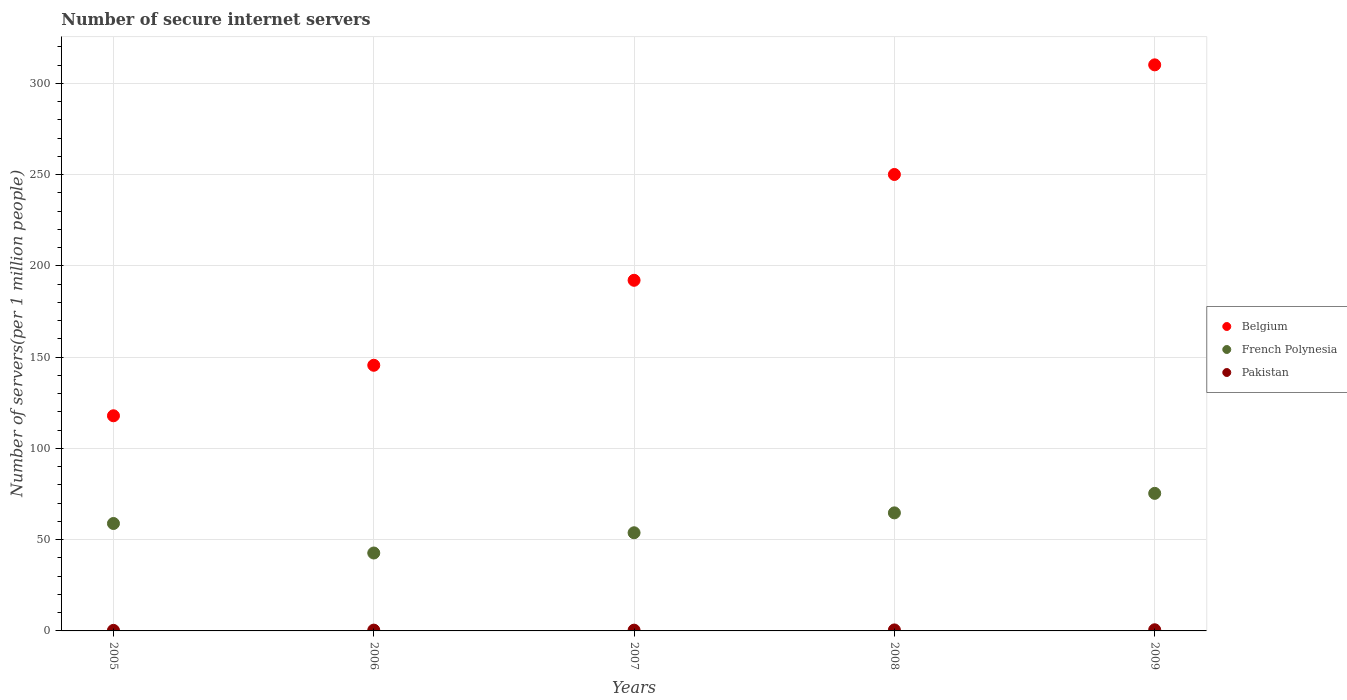Is the number of dotlines equal to the number of legend labels?
Your answer should be compact. Yes. What is the number of secure internet servers in Belgium in 2009?
Ensure brevity in your answer.  310.1. Across all years, what is the maximum number of secure internet servers in French Polynesia?
Your answer should be compact. 75.35. Across all years, what is the minimum number of secure internet servers in French Polynesia?
Give a very brief answer. 42.68. In which year was the number of secure internet servers in Pakistan maximum?
Your answer should be very brief. 2009. What is the total number of secure internet servers in French Polynesia in the graph?
Keep it short and to the point. 295.33. What is the difference between the number of secure internet servers in French Polynesia in 2006 and that in 2009?
Ensure brevity in your answer.  -32.67. What is the difference between the number of secure internet servers in Belgium in 2005 and the number of secure internet servers in French Polynesia in 2007?
Your answer should be compact. 64.09. What is the average number of secure internet servers in French Polynesia per year?
Make the answer very short. 59.07. In the year 2005, what is the difference between the number of secure internet servers in French Polynesia and number of secure internet servers in Belgium?
Provide a succinct answer. -59.01. What is the ratio of the number of secure internet servers in Belgium in 2007 to that in 2008?
Keep it short and to the point. 0.77. Is the number of secure internet servers in Pakistan in 2008 less than that in 2009?
Offer a terse response. Yes. Is the difference between the number of secure internet servers in French Polynesia in 2005 and 2007 greater than the difference between the number of secure internet servers in Belgium in 2005 and 2007?
Make the answer very short. Yes. What is the difference between the highest and the second highest number of secure internet servers in Pakistan?
Make the answer very short. 0.08. What is the difference between the highest and the lowest number of secure internet servers in Belgium?
Make the answer very short. 192.24. In how many years, is the number of secure internet servers in Pakistan greater than the average number of secure internet servers in Pakistan taken over all years?
Keep it short and to the point. 2. Does the number of secure internet servers in Pakistan monotonically increase over the years?
Your answer should be compact. No. How many years are there in the graph?
Make the answer very short. 5. What is the difference between two consecutive major ticks on the Y-axis?
Your response must be concise. 50. Where does the legend appear in the graph?
Keep it short and to the point. Center right. How many legend labels are there?
Your answer should be very brief. 3. What is the title of the graph?
Your answer should be very brief. Number of secure internet servers. Does "Central Europe" appear as one of the legend labels in the graph?
Offer a terse response. No. What is the label or title of the X-axis?
Offer a terse response. Years. What is the label or title of the Y-axis?
Your response must be concise. Number of servers(per 1 million people). What is the Number of servers(per 1 million people) in Belgium in 2005?
Give a very brief answer. 117.86. What is the Number of servers(per 1 million people) in French Polynesia in 2005?
Provide a succinct answer. 58.85. What is the Number of servers(per 1 million people) in Pakistan in 2005?
Ensure brevity in your answer.  0.3. What is the Number of servers(per 1 million people) of Belgium in 2006?
Offer a very short reply. 145.53. What is the Number of servers(per 1 million people) of French Polynesia in 2006?
Provide a succinct answer. 42.68. What is the Number of servers(per 1 million people) of Pakistan in 2006?
Your answer should be very brief. 0.44. What is the Number of servers(per 1 million people) of Belgium in 2007?
Your answer should be compact. 192.08. What is the Number of servers(per 1 million people) in French Polynesia in 2007?
Keep it short and to the point. 53.77. What is the Number of servers(per 1 million people) in Pakistan in 2007?
Offer a terse response. 0.42. What is the Number of servers(per 1 million people) in Belgium in 2008?
Give a very brief answer. 250.05. What is the Number of servers(per 1 million people) in French Polynesia in 2008?
Your response must be concise. 64.67. What is the Number of servers(per 1 million people) in Pakistan in 2008?
Offer a terse response. 0.55. What is the Number of servers(per 1 million people) of Belgium in 2009?
Offer a very short reply. 310.1. What is the Number of servers(per 1 million people) in French Polynesia in 2009?
Your answer should be very brief. 75.35. What is the Number of servers(per 1 million people) of Pakistan in 2009?
Offer a very short reply. 0.63. Across all years, what is the maximum Number of servers(per 1 million people) of Belgium?
Your answer should be compact. 310.1. Across all years, what is the maximum Number of servers(per 1 million people) in French Polynesia?
Offer a very short reply. 75.35. Across all years, what is the maximum Number of servers(per 1 million people) in Pakistan?
Your answer should be compact. 0.63. Across all years, what is the minimum Number of servers(per 1 million people) of Belgium?
Keep it short and to the point. 117.86. Across all years, what is the minimum Number of servers(per 1 million people) of French Polynesia?
Ensure brevity in your answer.  42.68. Across all years, what is the minimum Number of servers(per 1 million people) of Pakistan?
Provide a short and direct response. 0.3. What is the total Number of servers(per 1 million people) in Belgium in the graph?
Offer a terse response. 1015.61. What is the total Number of servers(per 1 million people) in French Polynesia in the graph?
Provide a short and direct response. 295.33. What is the total Number of servers(per 1 million people) in Pakistan in the graph?
Your response must be concise. 2.34. What is the difference between the Number of servers(per 1 million people) in Belgium in 2005 and that in 2006?
Offer a very short reply. -27.67. What is the difference between the Number of servers(per 1 million people) of French Polynesia in 2005 and that in 2006?
Give a very brief answer. 16.17. What is the difference between the Number of servers(per 1 million people) of Pakistan in 2005 and that in 2006?
Your answer should be very brief. -0.14. What is the difference between the Number of servers(per 1 million people) of Belgium in 2005 and that in 2007?
Keep it short and to the point. -74.22. What is the difference between the Number of servers(per 1 million people) of French Polynesia in 2005 and that in 2007?
Give a very brief answer. 5.08. What is the difference between the Number of servers(per 1 million people) of Pakistan in 2005 and that in 2007?
Provide a short and direct response. -0.12. What is the difference between the Number of servers(per 1 million people) in Belgium in 2005 and that in 2008?
Ensure brevity in your answer.  -132.19. What is the difference between the Number of servers(per 1 million people) in French Polynesia in 2005 and that in 2008?
Your answer should be compact. -5.82. What is the difference between the Number of servers(per 1 million people) of Pakistan in 2005 and that in 2008?
Your answer should be very brief. -0.25. What is the difference between the Number of servers(per 1 million people) in Belgium in 2005 and that in 2009?
Offer a terse response. -192.24. What is the difference between the Number of servers(per 1 million people) of French Polynesia in 2005 and that in 2009?
Your response must be concise. -16.5. What is the difference between the Number of servers(per 1 million people) of Pakistan in 2005 and that in 2009?
Provide a succinct answer. -0.33. What is the difference between the Number of servers(per 1 million people) of Belgium in 2006 and that in 2007?
Keep it short and to the point. -46.56. What is the difference between the Number of servers(per 1 million people) of French Polynesia in 2006 and that in 2007?
Your response must be concise. -11.09. What is the difference between the Number of servers(per 1 million people) of Pakistan in 2006 and that in 2007?
Offer a very short reply. 0.02. What is the difference between the Number of servers(per 1 million people) in Belgium in 2006 and that in 2008?
Provide a succinct answer. -104.52. What is the difference between the Number of servers(per 1 million people) of French Polynesia in 2006 and that in 2008?
Offer a very short reply. -21.99. What is the difference between the Number of servers(per 1 million people) in Pakistan in 2006 and that in 2008?
Provide a succinct answer. -0.1. What is the difference between the Number of servers(per 1 million people) of Belgium in 2006 and that in 2009?
Provide a succinct answer. -164.57. What is the difference between the Number of servers(per 1 million people) in French Polynesia in 2006 and that in 2009?
Ensure brevity in your answer.  -32.67. What is the difference between the Number of servers(per 1 million people) in Pakistan in 2006 and that in 2009?
Make the answer very short. -0.19. What is the difference between the Number of servers(per 1 million people) in Belgium in 2007 and that in 2008?
Offer a very short reply. -57.97. What is the difference between the Number of servers(per 1 million people) of French Polynesia in 2007 and that in 2008?
Offer a terse response. -10.9. What is the difference between the Number of servers(per 1 million people) of Pakistan in 2007 and that in 2008?
Your answer should be very brief. -0.13. What is the difference between the Number of servers(per 1 million people) of Belgium in 2007 and that in 2009?
Give a very brief answer. -118.02. What is the difference between the Number of servers(per 1 million people) of French Polynesia in 2007 and that in 2009?
Your answer should be very brief. -21.58. What is the difference between the Number of servers(per 1 million people) in Pakistan in 2007 and that in 2009?
Provide a short and direct response. -0.21. What is the difference between the Number of servers(per 1 million people) of Belgium in 2008 and that in 2009?
Provide a succinct answer. -60.05. What is the difference between the Number of servers(per 1 million people) in French Polynesia in 2008 and that in 2009?
Your answer should be compact. -10.69. What is the difference between the Number of servers(per 1 million people) of Pakistan in 2008 and that in 2009?
Your answer should be compact. -0.08. What is the difference between the Number of servers(per 1 million people) of Belgium in 2005 and the Number of servers(per 1 million people) of French Polynesia in 2006?
Your answer should be compact. 75.18. What is the difference between the Number of servers(per 1 million people) in Belgium in 2005 and the Number of servers(per 1 million people) in Pakistan in 2006?
Offer a very short reply. 117.42. What is the difference between the Number of servers(per 1 million people) of French Polynesia in 2005 and the Number of servers(per 1 million people) of Pakistan in 2006?
Provide a short and direct response. 58.41. What is the difference between the Number of servers(per 1 million people) of Belgium in 2005 and the Number of servers(per 1 million people) of French Polynesia in 2007?
Give a very brief answer. 64.09. What is the difference between the Number of servers(per 1 million people) in Belgium in 2005 and the Number of servers(per 1 million people) in Pakistan in 2007?
Your answer should be very brief. 117.44. What is the difference between the Number of servers(per 1 million people) of French Polynesia in 2005 and the Number of servers(per 1 million people) of Pakistan in 2007?
Keep it short and to the point. 58.43. What is the difference between the Number of servers(per 1 million people) of Belgium in 2005 and the Number of servers(per 1 million people) of French Polynesia in 2008?
Offer a very short reply. 53.19. What is the difference between the Number of servers(per 1 million people) in Belgium in 2005 and the Number of servers(per 1 million people) in Pakistan in 2008?
Keep it short and to the point. 117.31. What is the difference between the Number of servers(per 1 million people) of French Polynesia in 2005 and the Number of servers(per 1 million people) of Pakistan in 2008?
Provide a short and direct response. 58.3. What is the difference between the Number of servers(per 1 million people) of Belgium in 2005 and the Number of servers(per 1 million people) of French Polynesia in 2009?
Give a very brief answer. 42.5. What is the difference between the Number of servers(per 1 million people) of Belgium in 2005 and the Number of servers(per 1 million people) of Pakistan in 2009?
Your answer should be compact. 117.23. What is the difference between the Number of servers(per 1 million people) in French Polynesia in 2005 and the Number of servers(per 1 million people) in Pakistan in 2009?
Provide a succinct answer. 58.22. What is the difference between the Number of servers(per 1 million people) in Belgium in 2006 and the Number of servers(per 1 million people) in French Polynesia in 2007?
Provide a short and direct response. 91.75. What is the difference between the Number of servers(per 1 million people) of Belgium in 2006 and the Number of servers(per 1 million people) of Pakistan in 2007?
Your answer should be very brief. 145.11. What is the difference between the Number of servers(per 1 million people) of French Polynesia in 2006 and the Number of servers(per 1 million people) of Pakistan in 2007?
Offer a terse response. 42.26. What is the difference between the Number of servers(per 1 million people) in Belgium in 2006 and the Number of servers(per 1 million people) in French Polynesia in 2008?
Offer a terse response. 80.86. What is the difference between the Number of servers(per 1 million people) in Belgium in 2006 and the Number of servers(per 1 million people) in Pakistan in 2008?
Your answer should be compact. 144.98. What is the difference between the Number of servers(per 1 million people) in French Polynesia in 2006 and the Number of servers(per 1 million people) in Pakistan in 2008?
Offer a terse response. 42.13. What is the difference between the Number of servers(per 1 million people) in Belgium in 2006 and the Number of servers(per 1 million people) in French Polynesia in 2009?
Provide a short and direct response. 70.17. What is the difference between the Number of servers(per 1 million people) of Belgium in 2006 and the Number of servers(per 1 million people) of Pakistan in 2009?
Make the answer very short. 144.9. What is the difference between the Number of servers(per 1 million people) of French Polynesia in 2006 and the Number of servers(per 1 million people) of Pakistan in 2009?
Make the answer very short. 42.05. What is the difference between the Number of servers(per 1 million people) in Belgium in 2007 and the Number of servers(per 1 million people) in French Polynesia in 2008?
Ensure brevity in your answer.  127.41. What is the difference between the Number of servers(per 1 million people) of Belgium in 2007 and the Number of servers(per 1 million people) of Pakistan in 2008?
Ensure brevity in your answer.  191.54. What is the difference between the Number of servers(per 1 million people) of French Polynesia in 2007 and the Number of servers(per 1 million people) of Pakistan in 2008?
Your answer should be very brief. 53.23. What is the difference between the Number of servers(per 1 million people) in Belgium in 2007 and the Number of servers(per 1 million people) in French Polynesia in 2009?
Offer a very short reply. 116.73. What is the difference between the Number of servers(per 1 million people) in Belgium in 2007 and the Number of servers(per 1 million people) in Pakistan in 2009?
Provide a succinct answer. 191.45. What is the difference between the Number of servers(per 1 million people) in French Polynesia in 2007 and the Number of servers(per 1 million people) in Pakistan in 2009?
Provide a short and direct response. 53.14. What is the difference between the Number of servers(per 1 million people) in Belgium in 2008 and the Number of servers(per 1 million people) in French Polynesia in 2009?
Give a very brief answer. 174.69. What is the difference between the Number of servers(per 1 million people) of Belgium in 2008 and the Number of servers(per 1 million people) of Pakistan in 2009?
Make the answer very short. 249.42. What is the difference between the Number of servers(per 1 million people) in French Polynesia in 2008 and the Number of servers(per 1 million people) in Pakistan in 2009?
Provide a succinct answer. 64.04. What is the average Number of servers(per 1 million people) in Belgium per year?
Make the answer very short. 203.12. What is the average Number of servers(per 1 million people) in French Polynesia per year?
Offer a very short reply. 59.07. What is the average Number of servers(per 1 million people) in Pakistan per year?
Keep it short and to the point. 0.47. In the year 2005, what is the difference between the Number of servers(per 1 million people) in Belgium and Number of servers(per 1 million people) in French Polynesia?
Make the answer very short. 59.01. In the year 2005, what is the difference between the Number of servers(per 1 million people) in Belgium and Number of servers(per 1 million people) in Pakistan?
Your response must be concise. 117.56. In the year 2005, what is the difference between the Number of servers(per 1 million people) in French Polynesia and Number of servers(per 1 million people) in Pakistan?
Provide a succinct answer. 58.55. In the year 2006, what is the difference between the Number of servers(per 1 million people) in Belgium and Number of servers(per 1 million people) in French Polynesia?
Ensure brevity in your answer.  102.85. In the year 2006, what is the difference between the Number of servers(per 1 million people) in Belgium and Number of servers(per 1 million people) in Pakistan?
Provide a succinct answer. 145.09. In the year 2006, what is the difference between the Number of servers(per 1 million people) in French Polynesia and Number of servers(per 1 million people) in Pakistan?
Make the answer very short. 42.24. In the year 2007, what is the difference between the Number of servers(per 1 million people) of Belgium and Number of servers(per 1 million people) of French Polynesia?
Your answer should be compact. 138.31. In the year 2007, what is the difference between the Number of servers(per 1 million people) in Belgium and Number of servers(per 1 million people) in Pakistan?
Your response must be concise. 191.66. In the year 2007, what is the difference between the Number of servers(per 1 million people) in French Polynesia and Number of servers(per 1 million people) in Pakistan?
Provide a short and direct response. 53.35. In the year 2008, what is the difference between the Number of servers(per 1 million people) of Belgium and Number of servers(per 1 million people) of French Polynesia?
Keep it short and to the point. 185.38. In the year 2008, what is the difference between the Number of servers(per 1 million people) in Belgium and Number of servers(per 1 million people) in Pakistan?
Make the answer very short. 249.5. In the year 2008, what is the difference between the Number of servers(per 1 million people) of French Polynesia and Number of servers(per 1 million people) of Pakistan?
Your answer should be very brief. 64.12. In the year 2009, what is the difference between the Number of servers(per 1 million people) in Belgium and Number of servers(per 1 million people) in French Polynesia?
Keep it short and to the point. 234.75. In the year 2009, what is the difference between the Number of servers(per 1 million people) in Belgium and Number of servers(per 1 million people) in Pakistan?
Provide a succinct answer. 309.47. In the year 2009, what is the difference between the Number of servers(per 1 million people) in French Polynesia and Number of servers(per 1 million people) in Pakistan?
Your answer should be very brief. 74.72. What is the ratio of the Number of servers(per 1 million people) in Belgium in 2005 to that in 2006?
Provide a succinct answer. 0.81. What is the ratio of the Number of servers(per 1 million people) in French Polynesia in 2005 to that in 2006?
Give a very brief answer. 1.38. What is the ratio of the Number of servers(per 1 million people) of Pakistan in 2005 to that in 2006?
Your answer should be compact. 0.68. What is the ratio of the Number of servers(per 1 million people) of Belgium in 2005 to that in 2007?
Provide a short and direct response. 0.61. What is the ratio of the Number of servers(per 1 million people) of French Polynesia in 2005 to that in 2007?
Offer a very short reply. 1.09. What is the ratio of the Number of servers(per 1 million people) of Pakistan in 2005 to that in 2007?
Offer a very short reply. 0.72. What is the ratio of the Number of servers(per 1 million people) of Belgium in 2005 to that in 2008?
Your response must be concise. 0.47. What is the ratio of the Number of servers(per 1 million people) in French Polynesia in 2005 to that in 2008?
Make the answer very short. 0.91. What is the ratio of the Number of servers(per 1 million people) of Pakistan in 2005 to that in 2008?
Make the answer very short. 0.55. What is the ratio of the Number of servers(per 1 million people) in Belgium in 2005 to that in 2009?
Your response must be concise. 0.38. What is the ratio of the Number of servers(per 1 million people) in French Polynesia in 2005 to that in 2009?
Your response must be concise. 0.78. What is the ratio of the Number of servers(per 1 million people) in Pakistan in 2005 to that in 2009?
Offer a terse response. 0.48. What is the ratio of the Number of servers(per 1 million people) of Belgium in 2006 to that in 2007?
Your answer should be very brief. 0.76. What is the ratio of the Number of servers(per 1 million people) in French Polynesia in 2006 to that in 2007?
Give a very brief answer. 0.79. What is the ratio of the Number of servers(per 1 million people) in Pakistan in 2006 to that in 2007?
Keep it short and to the point. 1.05. What is the ratio of the Number of servers(per 1 million people) of Belgium in 2006 to that in 2008?
Your response must be concise. 0.58. What is the ratio of the Number of servers(per 1 million people) of French Polynesia in 2006 to that in 2008?
Offer a very short reply. 0.66. What is the ratio of the Number of servers(per 1 million people) in Pakistan in 2006 to that in 2008?
Make the answer very short. 0.81. What is the ratio of the Number of servers(per 1 million people) in Belgium in 2006 to that in 2009?
Give a very brief answer. 0.47. What is the ratio of the Number of servers(per 1 million people) of French Polynesia in 2006 to that in 2009?
Ensure brevity in your answer.  0.57. What is the ratio of the Number of servers(per 1 million people) of Pakistan in 2006 to that in 2009?
Give a very brief answer. 0.7. What is the ratio of the Number of servers(per 1 million people) of Belgium in 2007 to that in 2008?
Offer a terse response. 0.77. What is the ratio of the Number of servers(per 1 million people) of French Polynesia in 2007 to that in 2008?
Provide a succinct answer. 0.83. What is the ratio of the Number of servers(per 1 million people) in Pakistan in 2007 to that in 2008?
Ensure brevity in your answer.  0.77. What is the ratio of the Number of servers(per 1 million people) of Belgium in 2007 to that in 2009?
Make the answer very short. 0.62. What is the ratio of the Number of servers(per 1 million people) in French Polynesia in 2007 to that in 2009?
Your response must be concise. 0.71. What is the ratio of the Number of servers(per 1 million people) in Pakistan in 2007 to that in 2009?
Provide a succinct answer. 0.67. What is the ratio of the Number of servers(per 1 million people) of Belgium in 2008 to that in 2009?
Give a very brief answer. 0.81. What is the ratio of the Number of servers(per 1 million people) of French Polynesia in 2008 to that in 2009?
Keep it short and to the point. 0.86. What is the ratio of the Number of servers(per 1 million people) of Pakistan in 2008 to that in 2009?
Provide a succinct answer. 0.87. What is the difference between the highest and the second highest Number of servers(per 1 million people) in Belgium?
Offer a terse response. 60.05. What is the difference between the highest and the second highest Number of servers(per 1 million people) of French Polynesia?
Ensure brevity in your answer.  10.69. What is the difference between the highest and the second highest Number of servers(per 1 million people) in Pakistan?
Keep it short and to the point. 0.08. What is the difference between the highest and the lowest Number of servers(per 1 million people) of Belgium?
Keep it short and to the point. 192.24. What is the difference between the highest and the lowest Number of servers(per 1 million people) of French Polynesia?
Keep it short and to the point. 32.67. What is the difference between the highest and the lowest Number of servers(per 1 million people) in Pakistan?
Ensure brevity in your answer.  0.33. 